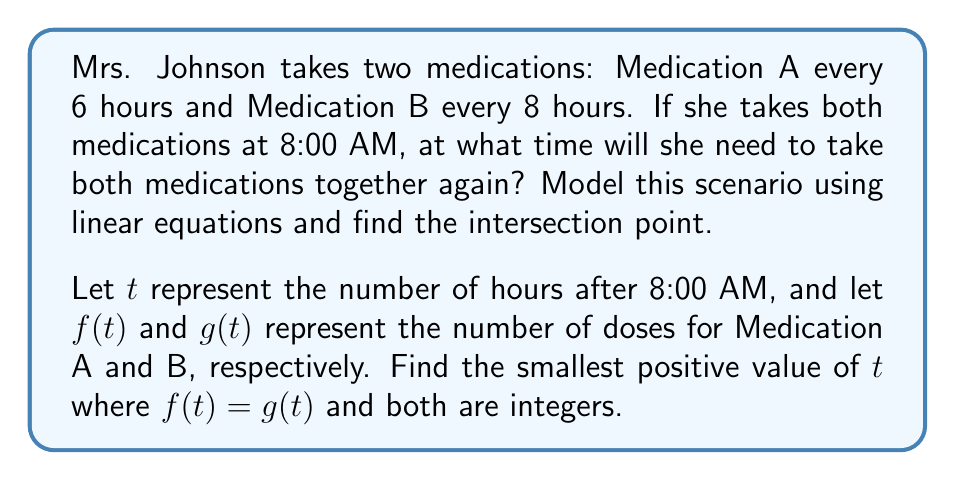Give your solution to this math problem. 1) First, let's set up the equations for each medication:

   Medication A: $f(t) = \frac{t}{6}$
   Medication B: $g(t) = \frac{t}{8}$

2) We need to find where these equations intersect and both result in integers:

   $\frac{t}{6} = \frac{t}{8} = n$, where $n$ is an integer

3) To solve this, we can use the least common multiple (LCM) of 6 and 8:

   $LCM(6,8) = 24$

4) This means that after 24 hours, both medications will have been taken an integer number of times:

   For Medication A: $\frac{24}{6} = 4$ doses
   For Medication B: $\frac{24}{8} = 3$ doses

5) Therefore, at $t = 24$ hours after 8:00 AM, Mrs. Johnson will need to take both medications again.

6) To convert this to a time:
   24 hours after 8:00 AM is 8:00 AM the next day.
Answer: 8:00 AM the next day 